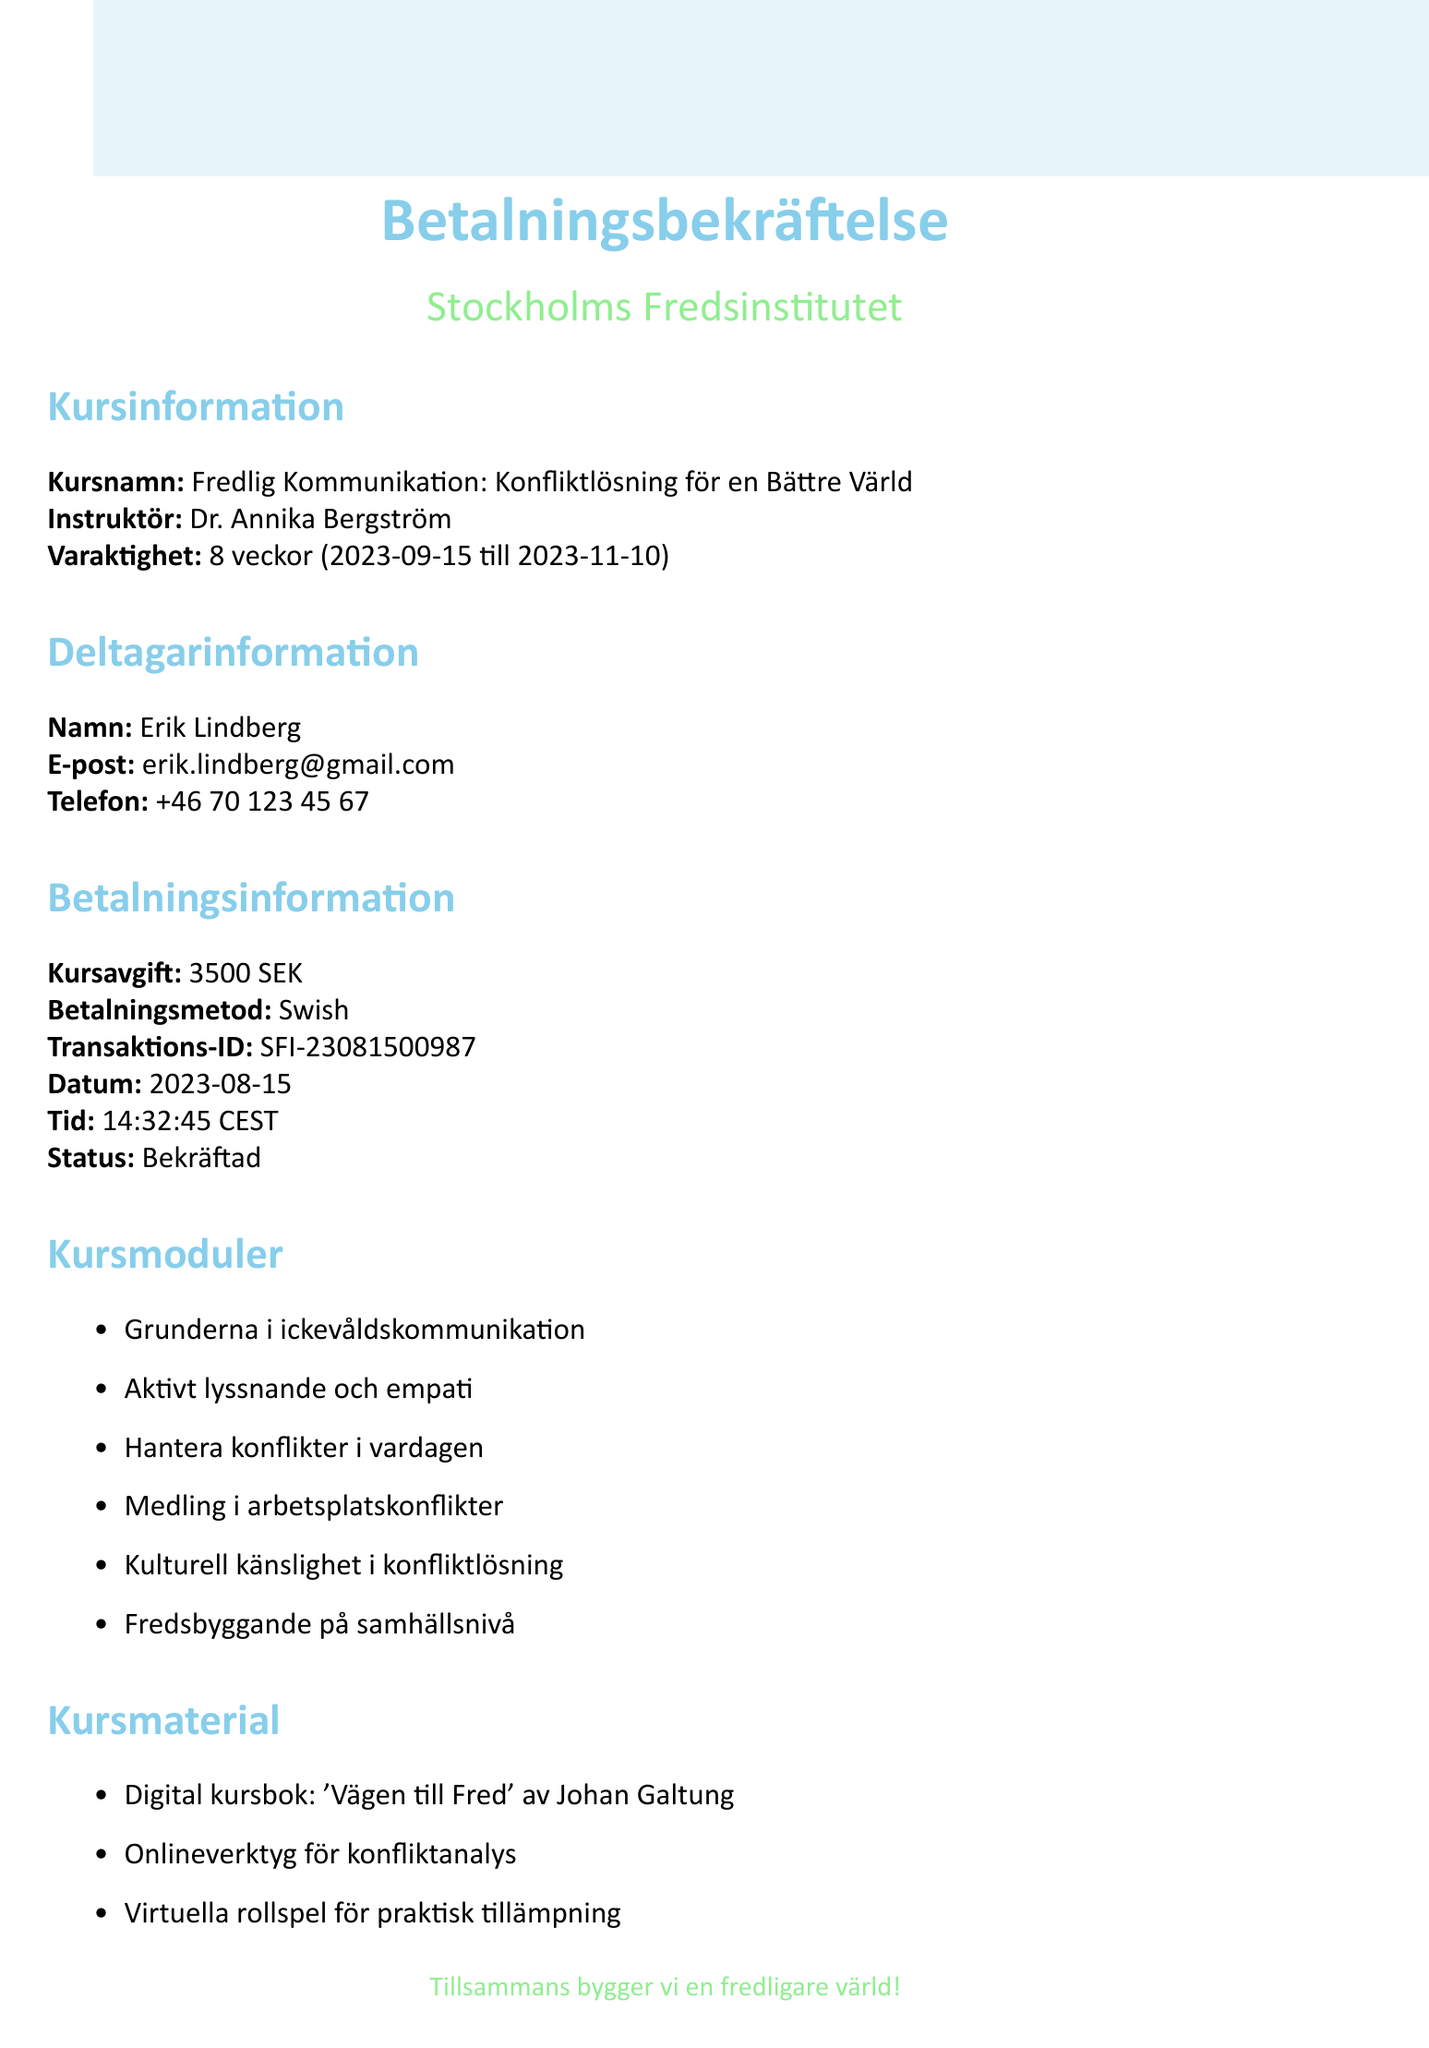what is the course name? The course name is mentioned in the document as the title of the course, which is "Fredlig Kommunikation: Konfliktlösning för en Bättre Värld."
Answer: Fredlig Kommunikation: Konfliktlösning för en Bättre Värld who is the instructor? The instructor's name is listed directly in the course information section of the document.
Answer: Dr. Annika Bergström what is the course duration? The duration of the course is specified in weeks, along with start and end dates.
Answer: 8 veckor when does the course start? The start date of the course is indicated in the course information section.
Answer: 2023-09-15 what is the course fee? The document specifies the amount and currency for the course fee.
Answer: 3500 SEK what payment method was used? The method of payment is noted under the payment information section of the document.
Answer: Swish what is the transaction ID? The transaction ID is directly included in the payment information segment of the document.
Answer: SFI-23081500987 is there a refund policy? The document outlines the refund policy, indicating the ability to receive a full refund within a specific time frame.
Answer: Full återbetalning möjlig inom 14 dagar efter kursstart what certification will be received? The certificate awarded for course completion is stated in the document.
Answer: Certifikat i Konfliktlösning och Ickevåldskommunikation what technical requirement is specified? The document mentions specific technical requirements necessary for participating in the course.
Answer: Stabil internetuppkoppling och dator med mikrofon och kamera 